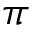<formula> <loc_0><loc_0><loc_500><loc_500>\pi</formula> 